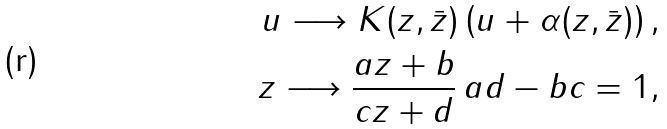<formula> <loc_0><loc_0><loc_500><loc_500>u \longrightarrow K ( z , \bar { z } ) \left ( u + \alpha ( z , \bar { z } ) \right ) , \\ z \longrightarrow \frac { a z + b } { c z + d } \, a d - b c = 1 ,</formula> 